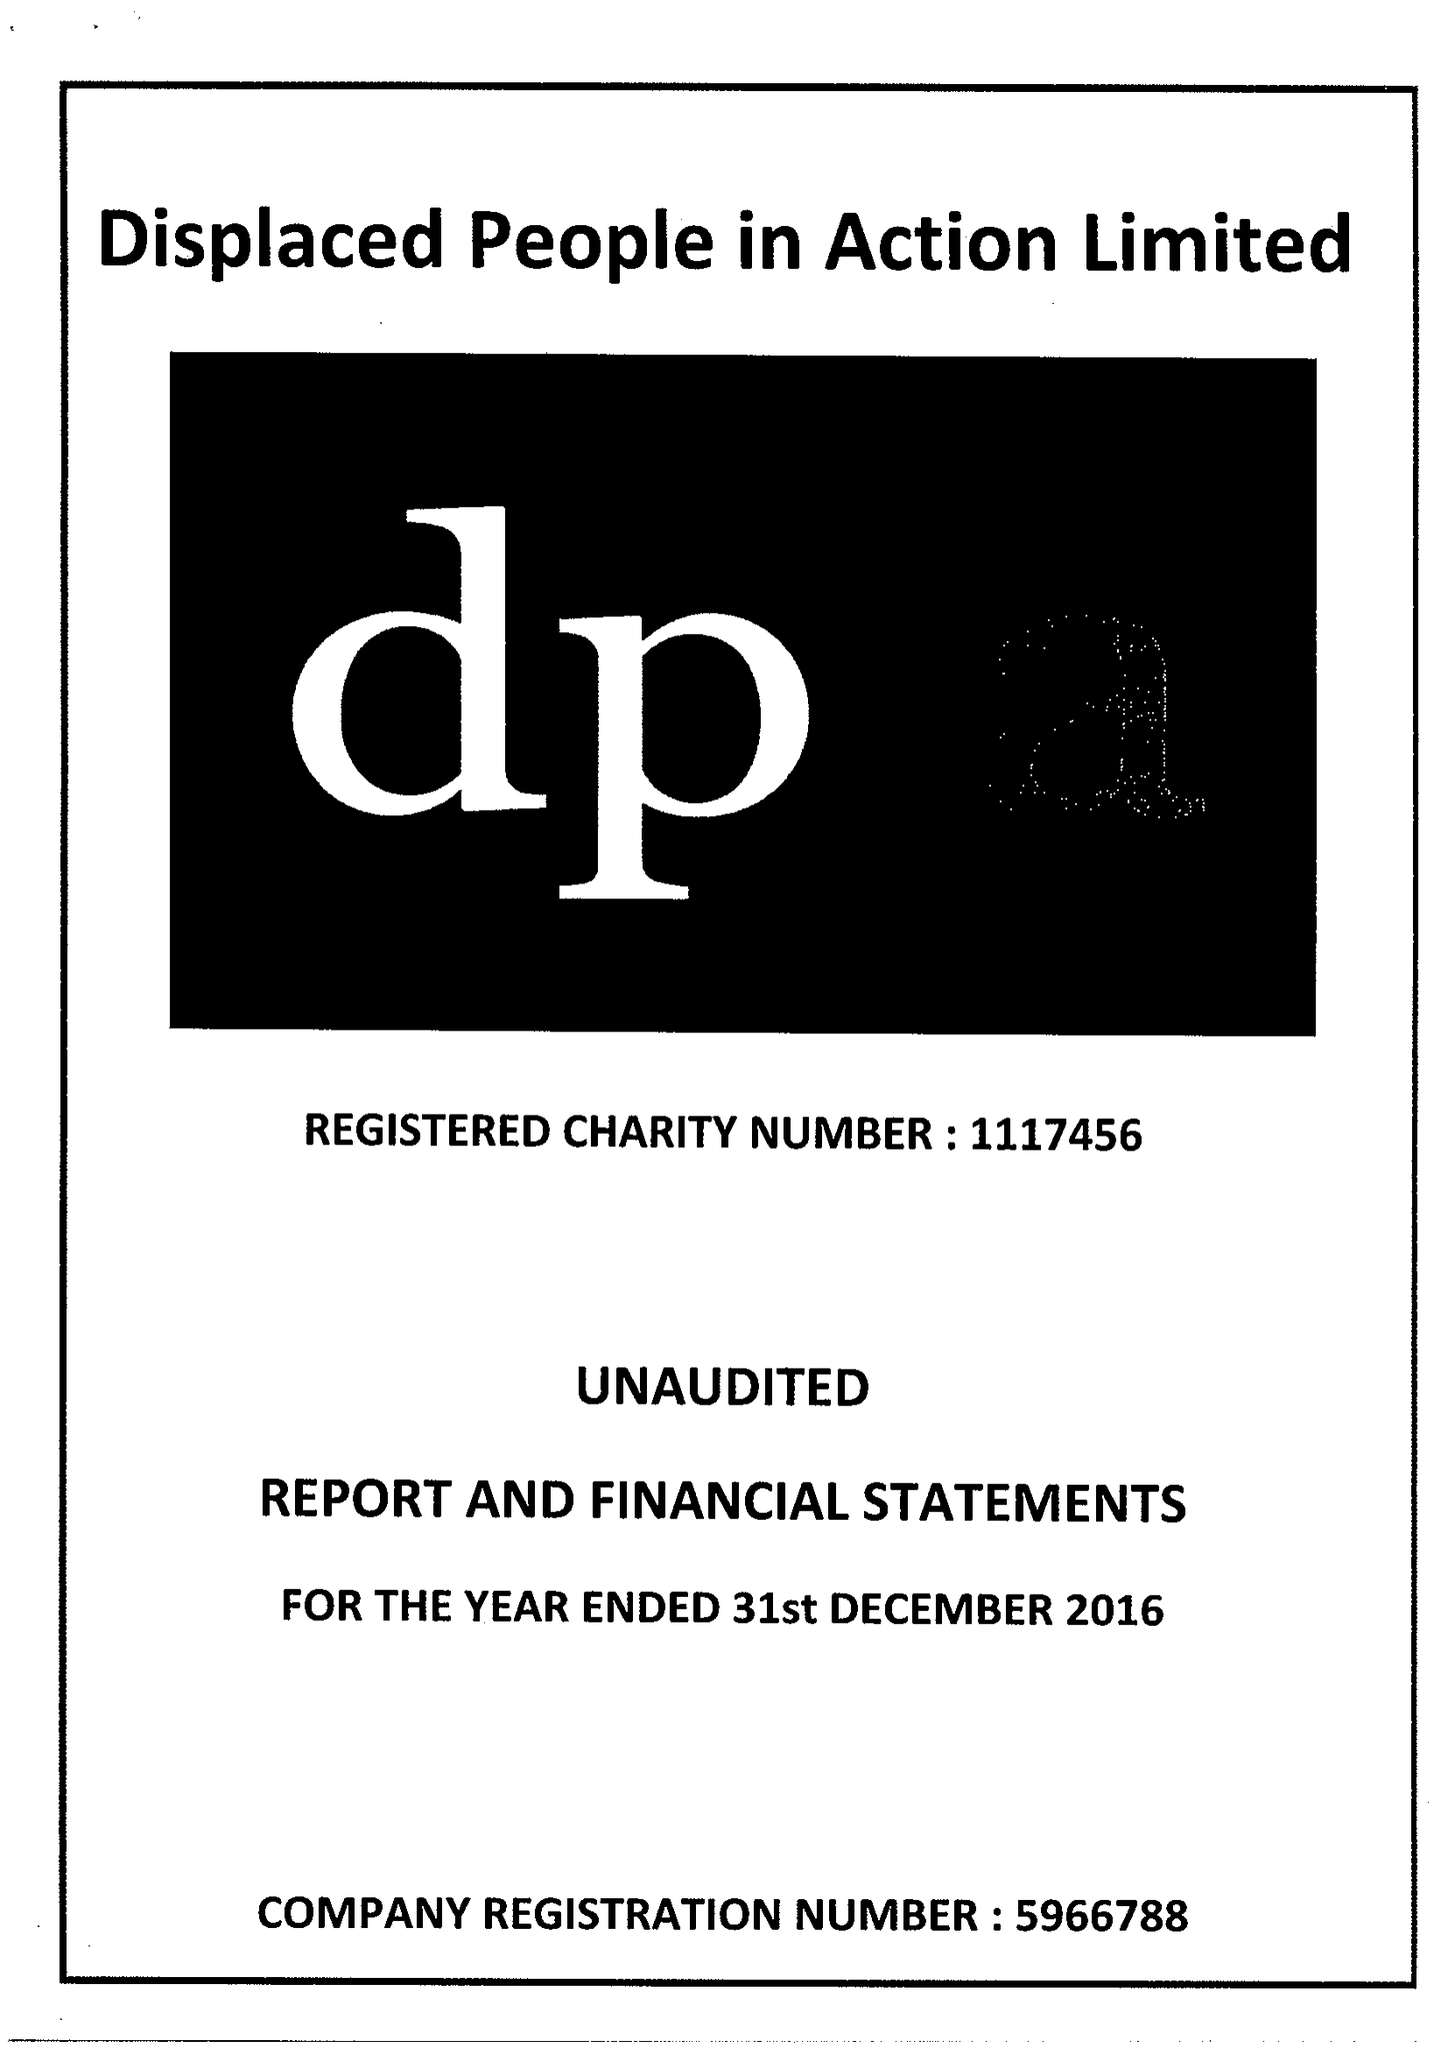What is the value for the income_annually_in_british_pounds?
Answer the question using a single word or phrase. 438631.00 